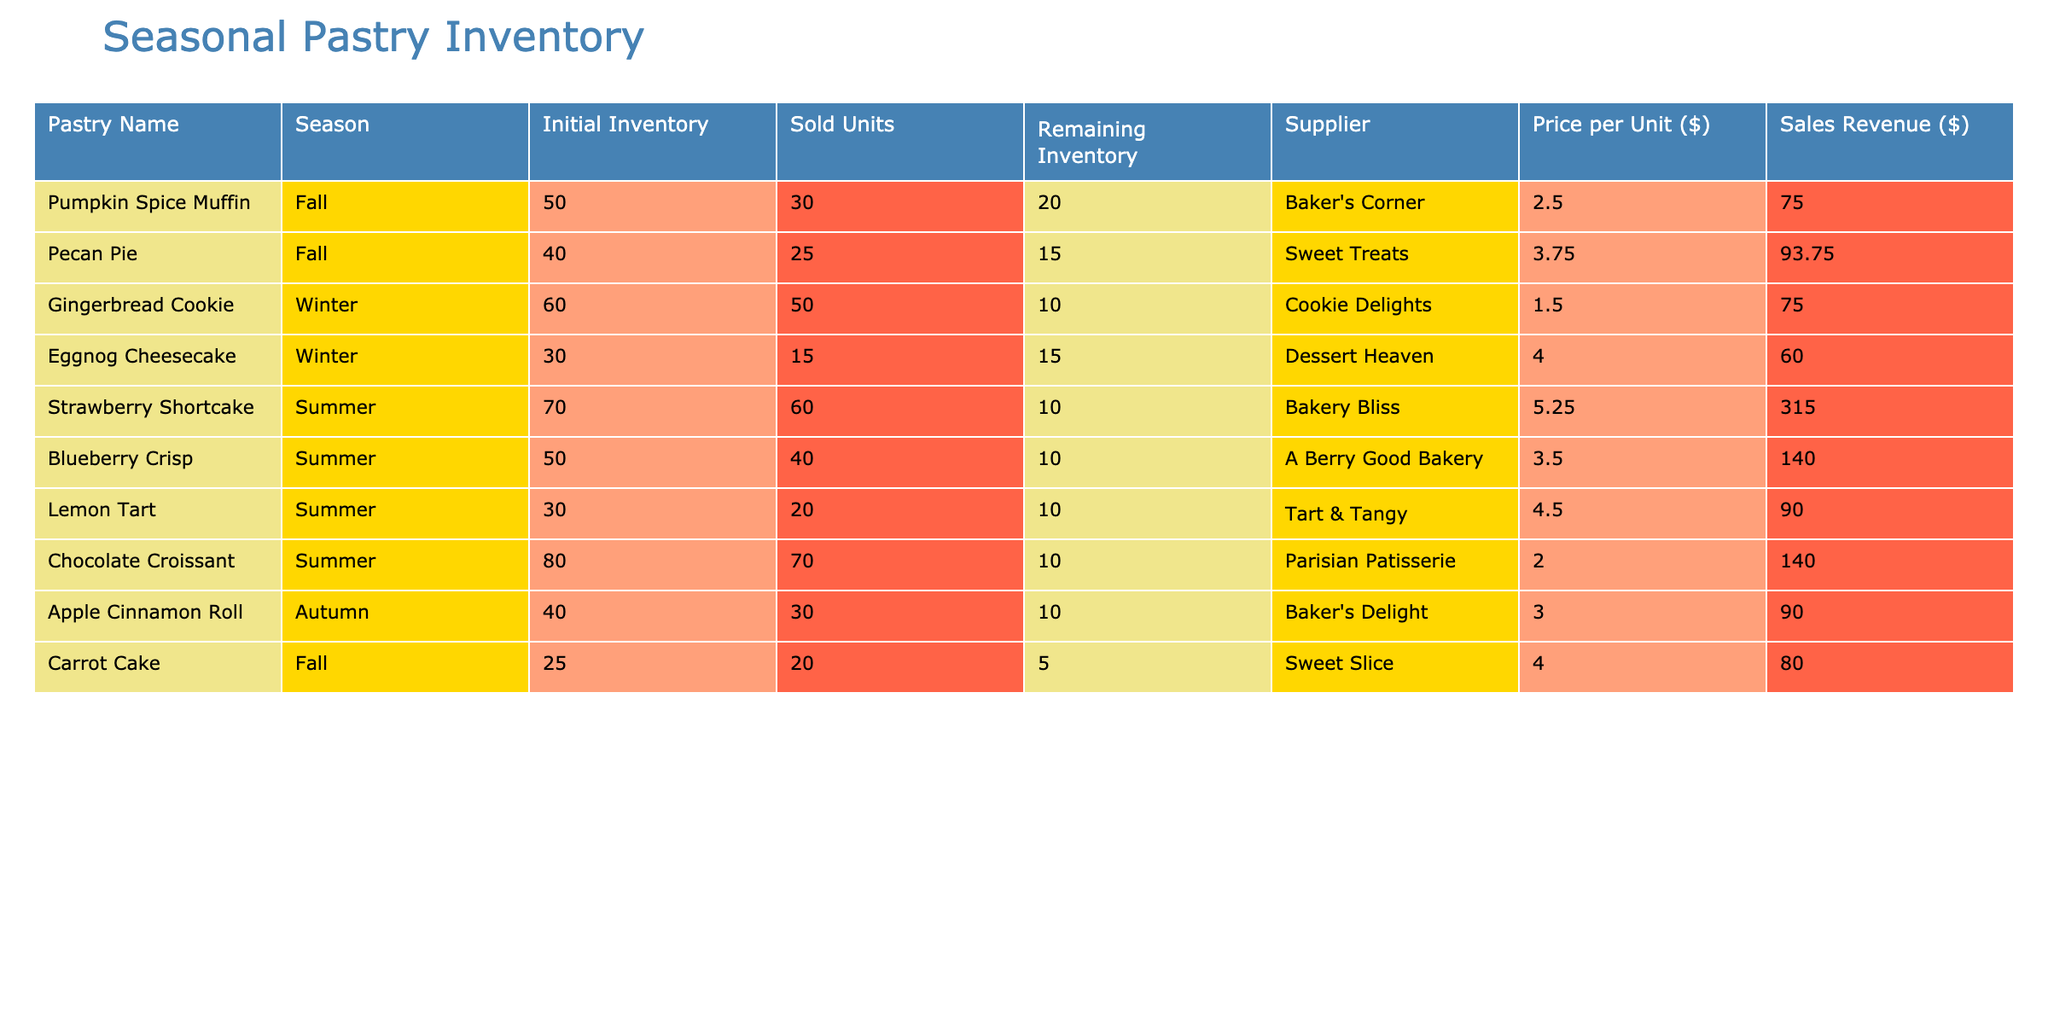What is the total sales revenue from the Summer pastries? To find the total sales revenue from Summer pastries, we need to check the sales revenue column for each of the Summer pastries: Strawberry Shortcake (315.00), Blueberry Crisp (140.00), Lemon Tart (90.00), and Chocolate Croissant (140.00). Now, sum these values: 315.00 + 140.00 + 90.00 + 140.00 = 685.00.
Answer: 685.00 Which pastry has the highest sales revenue in the Fall season? From the Fall pastries listed, we have: Pumpkin Spice Muffin (75.00), Pecan Pie (93.75), and Carrot Cake (80.00). Comparing their sales revenues, Pecan Pie has the highest sales revenue at 93.75.
Answer: Pecan Pie Is the remaining inventory for the Gingerbread Cookie greater than the sold units? The remaining inventory for the Gingerbread Cookie is 10, while the sold units are 50. Since 10 is not greater than 50, the answer is no.
Answer: No What is the average price per unit of the pastries available in Winter? For Winter pastries, we have the following prices: Gingerbread Cookie (1.50) and Eggnog Cheesecake (4.00). To find the average, sum these prices: 1.50 + 4.00 = 5.50. Then divide by the count of Winter pastries, which is 2: 5.50 / 2 = 2.75.
Answer: 2.75 Does the Carrot Cake have more sold units than the remaining inventory? The Carrot Cake has 20 sold units and a remaining inventory of 5. Since 20 is greater than 5, the answer is yes.
Answer: Yes What is the total initial inventory of all pastries listed in the table? We will sum the initial inventory of all pastries: Pumpkin Spice Muffin (50) + Pecan Pie (40) + Gingerbread Cookie (60) + Eggnog Cheesecake (30) + Strawberry Shortcake (70) + Blueberry Crisp (50) + Lemon Tart (30) + Chocolate Croissant (80) + Apple Cinnamon Roll (40) + Carrot Cake (25) =  50 + 40 + 60 + 30 + 70 + 50 + 30 + 80 + 40 + 25 =  475.
Answer: 475 Which pastry sold the fewest units during the Summer season? In the Summer season, the pastries sold are: Strawberry Shortcake (60), Blueberry Crisp (40), Lemon Tart (20), and Chocolate Croissant (70). Lemon Tart sold the fewest units with 20 sold.
Answer: Lemon Tart How much total sales revenue was generated from the pastries in the Autumn season? The pastries in the Autumn season are Apple Cinnamon Roll (90.00) and Carrot Cake (80.00). Adding their sales revenue gives: 90.00 + 80.00 = 170.00.
Answer: 170.00 